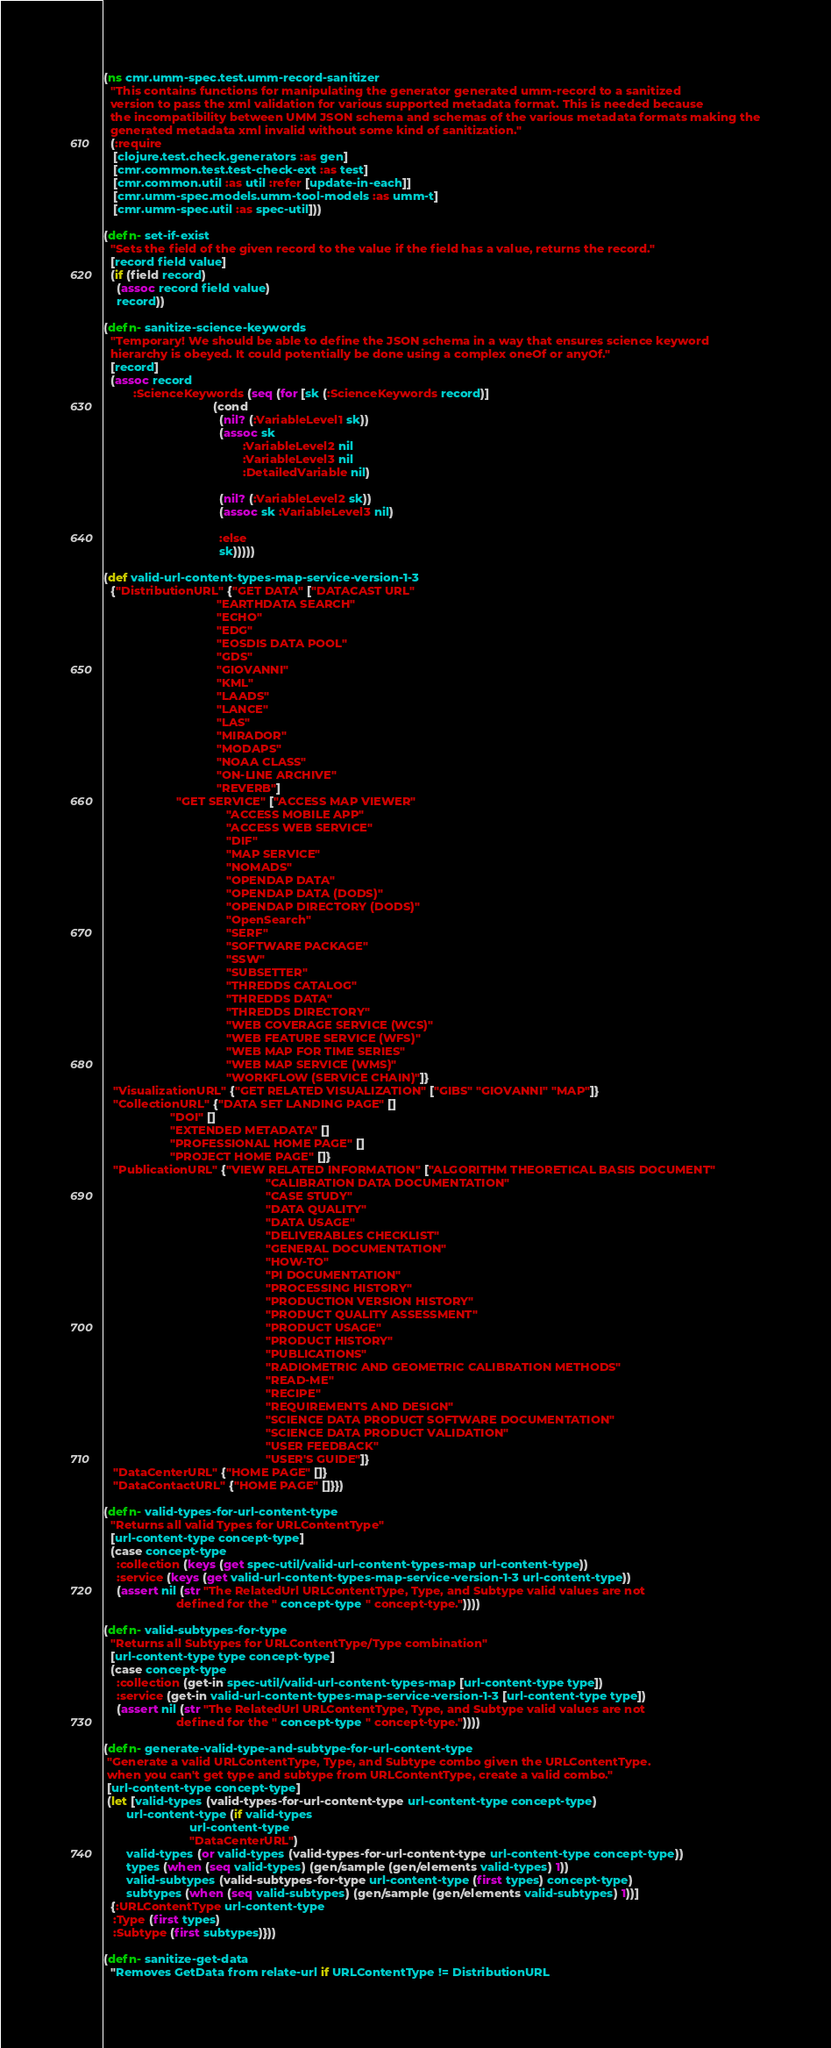Convert code to text. <code><loc_0><loc_0><loc_500><loc_500><_Clojure_>(ns cmr.umm-spec.test.umm-record-sanitizer
  "This contains functions for manipulating the generator generated umm-record to a sanitized
  version to pass the xml validation for various supported metadata format. This is needed because
  the incompatibility between UMM JSON schema and schemas of the various metadata formats making the
  generated metadata xml invalid without some kind of sanitization."
  (:require
   [clojure.test.check.generators :as gen]
   [cmr.common.test.test-check-ext :as test]
   [cmr.common.util :as util :refer [update-in-each]]
   [cmr.umm-spec.models.umm-tool-models :as umm-t]
   [cmr.umm-spec.util :as spec-util]))

(defn- set-if-exist
  "Sets the field of the given record to the value if the field has a value, returns the record."
  [record field value]
  (if (field record)
    (assoc record field value)
    record))

(defn- sanitize-science-keywords
  "Temporary! We should be able to define the JSON schema in a way that ensures science keyword
  hierarchy is obeyed. It could potentially be done using a complex oneOf or anyOf."
  [record]
  (assoc record
         :ScienceKeywords (seq (for [sk (:ScienceKeywords record)]
                                 (cond
                                   (nil? (:VariableLevel1 sk))
                                   (assoc sk
                                          :VariableLevel2 nil
                                          :VariableLevel3 nil
                                          :DetailedVariable nil)

                                   (nil? (:VariableLevel2 sk))
                                   (assoc sk :VariableLevel3 nil)

                                   :else
                                   sk)))))

(def valid-url-content-types-map-service-version-1-3
  {"DistributionURL" {"GET DATA" ["DATACAST URL"
                                  "EARTHDATA SEARCH"
                                  "ECHO"
                                  "EDG"
                                  "EOSDIS DATA POOL"
                                  "GDS"
                                  "GIOVANNI"
                                  "KML"
                                  "LAADS"
                                  "LANCE"
                                  "LAS"
                                  "MIRADOR"
                                  "MODAPS"
                                  "NOAA CLASS"
                                  "ON-LINE ARCHIVE"
                                  "REVERB"]
                      "GET SERVICE" ["ACCESS MAP VIEWER"
                                     "ACCESS MOBILE APP"
                                     "ACCESS WEB SERVICE"
                                     "DIF"
                                     "MAP SERVICE"
                                     "NOMADS"
                                     "OPENDAP DATA"
                                     "OPENDAP DATA (DODS)"
                                     "OPENDAP DIRECTORY (DODS)"
                                     "OpenSearch"
                                     "SERF"
                                     "SOFTWARE PACKAGE"
                                     "SSW"
                                     "SUBSETTER"
                                     "THREDDS CATALOG"
                                     "THREDDS DATA"
                                     "THREDDS DIRECTORY"
                                     "WEB COVERAGE SERVICE (WCS)"
                                     "WEB FEATURE SERVICE (WFS)"
                                     "WEB MAP FOR TIME SERIES"
                                     "WEB MAP SERVICE (WMS)"
                                     "WORKFLOW (SERVICE CHAIN)"]}
   "VisualizationURL" {"GET RELATED VISUALIZATION" ["GIBS" "GIOVANNI" "MAP"]}
   "CollectionURL" {"DATA SET LANDING PAGE" []
                    "DOI" []
                    "EXTENDED METADATA" []
                    "PROFESSIONAL HOME PAGE" []
                    "PROJECT HOME PAGE" []}
   "PublicationURL" {"VIEW RELATED INFORMATION" ["ALGORITHM THEORETICAL BASIS DOCUMENT"
                                                 "CALIBRATION DATA DOCUMENTATION"
                                                 "CASE STUDY"
                                                 "DATA QUALITY"
                                                 "DATA USAGE"
                                                 "DELIVERABLES CHECKLIST"
                                                 "GENERAL DOCUMENTATION"
                                                 "HOW-TO"
                                                 "PI DOCUMENTATION"
                                                 "PROCESSING HISTORY"
                                                 "PRODUCTION VERSION HISTORY"
                                                 "PRODUCT QUALITY ASSESSMENT"
                                                 "PRODUCT USAGE"
                                                 "PRODUCT HISTORY"
                                                 "PUBLICATIONS"
                                                 "RADIOMETRIC AND GEOMETRIC CALIBRATION METHODS"
                                                 "READ-ME"
                                                 "RECIPE"
                                                 "REQUIREMENTS AND DESIGN"
                                                 "SCIENCE DATA PRODUCT SOFTWARE DOCUMENTATION"
                                                 "SCIENCE DATA PRODUCT VALIDATION"
                                                 "USER FEEDBACK"
                                                 "USER'S GUIDE"]}
   "DataCenterURL" {"HOME PAGE" []}
   "DataContactURL" {"HOME PAGE" []}})

(defn- valid-types-for-url-content-type
  "Returns all valid Types for URLContentType"
  [url-content-type concept-type]
  (case concept-type
    :collection (keys (get spec-util/valid-url-content-types-map url-content-type))
    :service (keys (get valid-url-content-types-map-service-version-1-3 url-content-type))
    (assert nil (str "The RelatedUrl URLContentType, Type, and Subtype valid values are not
                      defined for the " concept-type " concept-type."))))

(defn- valid-subtypes-for-type
  "Returns all Subtypes for URLContentType/Type combination"
  [url-content-type type concept-type]
  (case concept-type
    :collection (get-in spec-util/valid-url-content-types-map [url-content-type type])
    :service (get-in valid-url-content-types-map-service-version-1-3 [url-content-type type])
    (assert nil (str "The RelatedUrl URLContentType, Type, and Subtype valid values are not
                      defined for the " concept-type " concept-type."))))

(defn- generate-valid-type-and-subtype-for-url-content-type
 "Generate a valid URLContentType, Type, and Subtype combo given the URLContentType.
 when you can't get type and subtype from URLContentType, create a valid combo."
 [url-content-type concept-type]
 (let [valid-types (valid-types-for-url-content-type url-content-type concept-type)
       url-content-type (if valid-types
                          url-content-type
                          "DataCenterURL")
       valid-types (or valid-types (valid-types-for-url-content-type url-content-type concept-type))
       types (when (seq valid-types) (gen/sample (gen/elements valid-types) 1))
       valid-subtypes (valid-subtypes-for-type url-content-type (first types) concept-type)
       subtypes (when (seq valid-subtypes) (gen/sample (gen/elements valid-subtypes) 1))]
  {:URLContentType url-content-type
   :Type (first types)
   :Subtype (first subtypes)}))

(defn- sanitize-get-data
  "Removes GetData from relate-url if URLContentType != DistributionURL</code> 